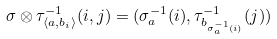Convert formula to latex. <formula><loc_0><loc_0><loc_500><loc_500>\sigma \otimes \tau _ { \langle a , b _ { i } \rangle } ^ { - 1 } ( i , j ) = ( \sigma _ { a } ^ { - 1 } ( i ) , \tau _ { b _ { \sigma _ { a } ^ { - 1 } ( i ) } } ^ { - 1 } ( j ) )</formula> 